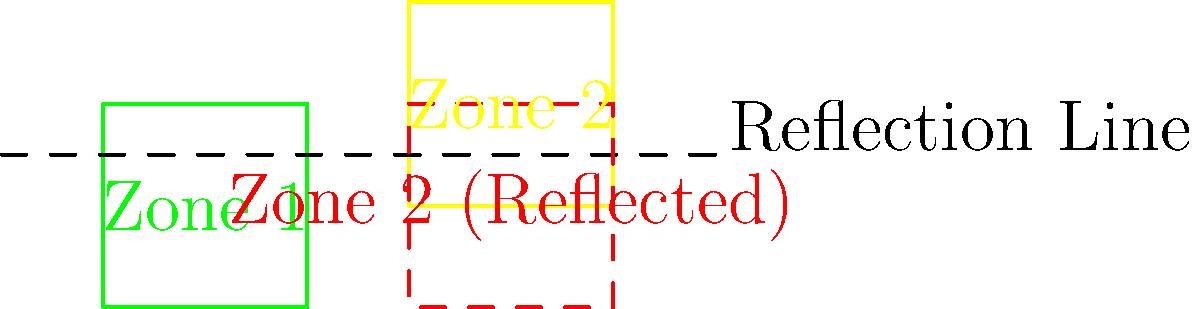In the diagram, two agricultural zones of Nigeria are represented: Zone 1 (green) and Zone 2 (yellow). To optimize foreign investment distribution, Zone 2 is reflected across the dashed line. What is the area of overlap between Zone 1 and the reflected Zone 2? To solve this problem, we need to follow these steps:

1) First, we need to identify the coordinates of the vertices of Zone 1 and the reflected Zone 2.

   Zone 1: A(0,0), B(2,0), C(2,2), D(0,2)
   Reflected Zone 2: E'(3,0), F'(5,0), G'(5,2), H'(3,2)

2) We can see that the overlap forms a rectangle.

3) To find the area of overlap, we need to determine the width and height of this rectangle:

   Width: The x-coordinate where Zone 1 ends (2) minus the x-coordinate where reflected Zone 2 starts (3).
   $w = 3 - 2 = 1$

   Height: The y-coordinate where Zone 1 ends (2) is the same as where reflected Zone 2 ends.
   $h = 2$

4) The area of a rectangle is given by the formula: $A = w * h$

5) Substituting our values:

   $A = 1 * 2 = 2$ square units

Therefore, the area of overlap between Zone 1 and the reflected Zone 2 is 2 square units.
Answer: 2 square units 